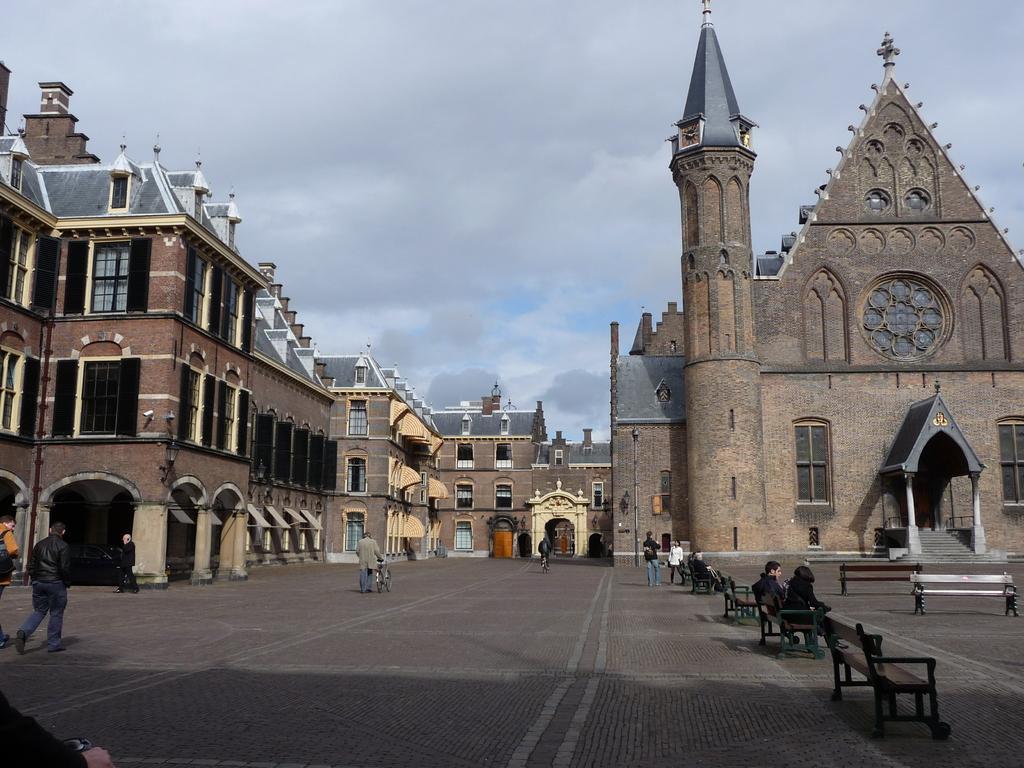Can you describe this image briefly? These two people sitting on the bench and we can see benches. Left side of the image these two people walking and there is a person walking and holding bicycle. Background we can see buildings and sky. 